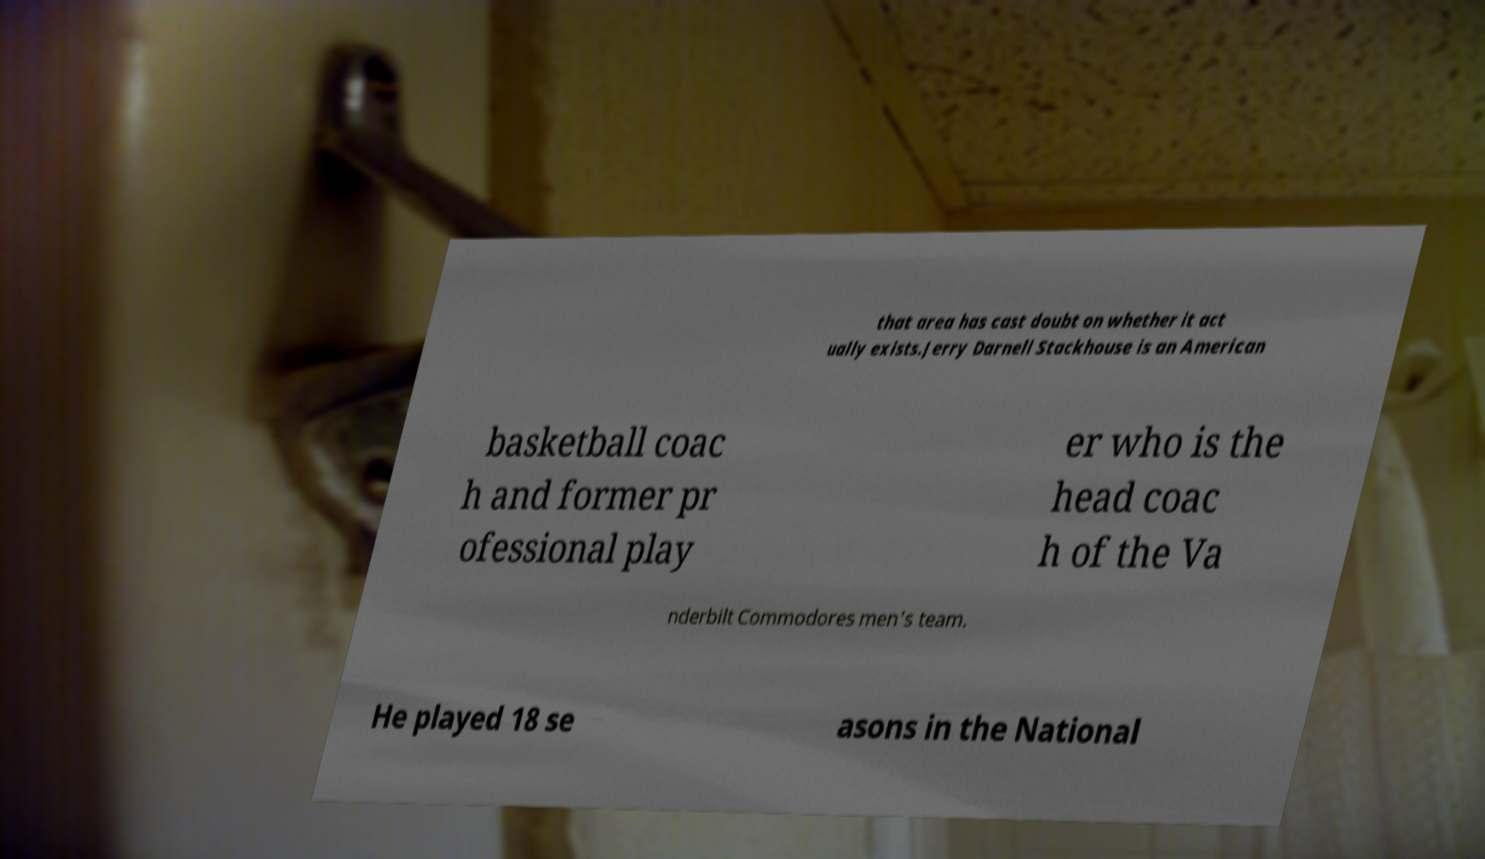For documentation purposes, I need the text within this image transcribed. Could you provide that? that area has cast doubt on whether it act ually exists.Jerry Darnell Stackhouse is an American basketball coac h and former pr ofessional play er who is the head coac h of the Va nderbilt Commodores men's team. He played 18 se asons in the National 